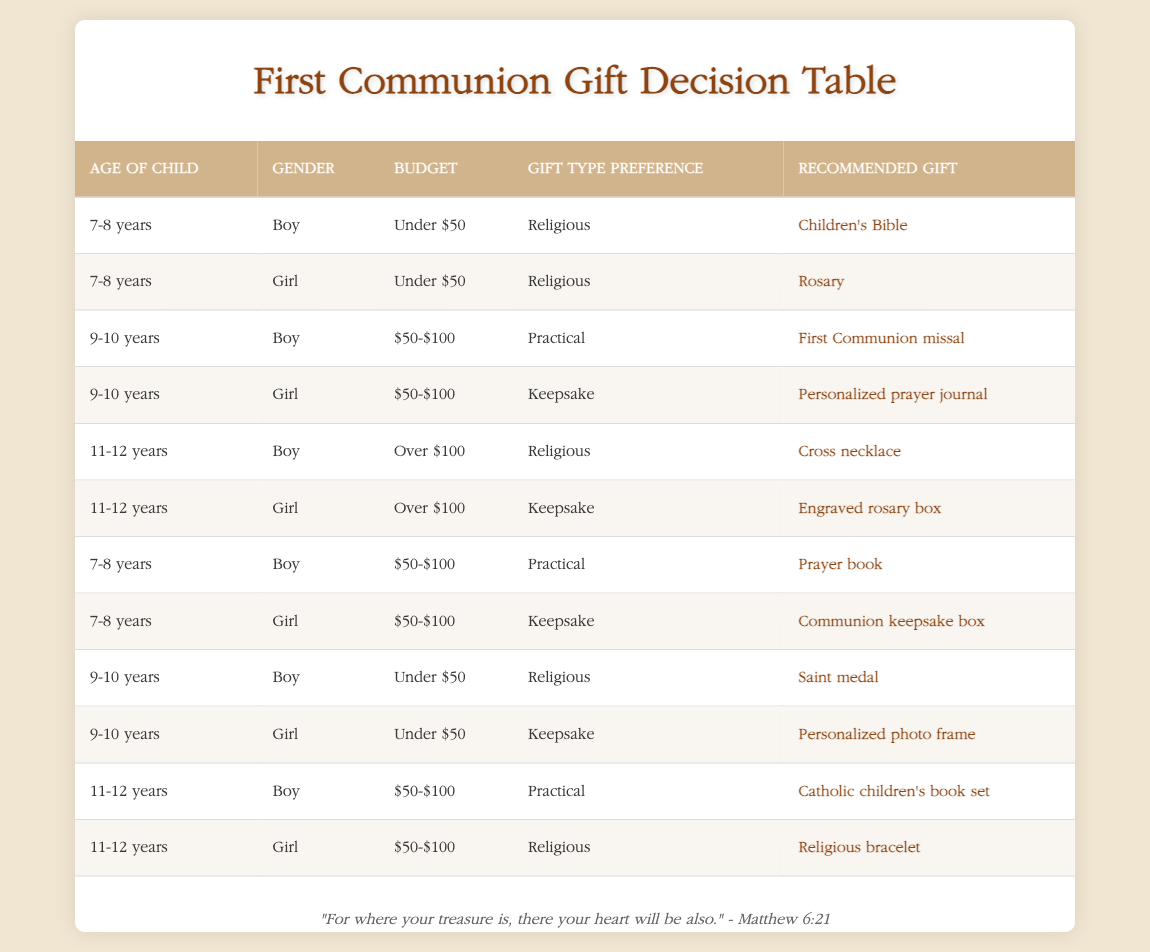What gift is recommended for a 9-10-year-old boy with a budget under $50? According to the table, the conditions for a 9-10-year-old boy with a budget under $50 lead to the action of receiving a Saint medal.
Answer: Saint medal What is the recommended gift for an 11-12-year-old girl with a budget between $50 and $100? The table specifies that for an 11-12-year-old girl with a $50-$100 budget and a preference for religious gifts, the recommended gift is a Religious bracelet.
Answer: Religious bracelet Are there any gifts recommended for 7-8-year-old boys that are practical and cost between $50 and $100? Yes, the table indicates that for 7-8-year-old boys who prefer practical gifts and have a budget of $50-$100, the recommended gift is a Prayer book.
Answer: Yes What is the total number of recommended gifts for 11-12-year-old boys? Looking at the table, the recommendations for 11-12-year-old boys include a Cross necklace, Catholic children's book set, making a total of 2 gifts.
Answer: 2 Is a Personalized prayer journal recommended for 9-10-year-old boys with a budget of $50 to $100? No, based on the table, a Personalized prayer journal is specifically recommended for 9-10-year-old girls with a budget of $50-$100, not for boys.
Answer: No If I have a budget over $100, what religious gift is recommended for an 11-12-year-old boy? The table shows that with a budget over $100 for an 11-12-year-old boy, the recommended religious gift is a Cross necklace.
Answer: Cross necklace For girls aged 7-8, what are the recommended gifts available under $50? The table indicates that for girls aged 7-8 with a budget under $50 and a religious preference, the recommended gift is a Rosary. Thus, there is only one recommendation for this age group and budget.
Answer: Rosary Which gift is suggested for a 9-10-year-old girl who prefers keepsake gifts and has a budget under $50? According to the table, a 9-10-year-old girl with a keepsake preference and budget under $50 would receive a Personalized photo frame as the recommended gift.
Answer: Personalized photo frame In total, how many different gifts are suggested for boys? By examining the table, the gifts recommended for boys include the Children's Bible, Saint medal, Cross necklace, Prayer book, and Catholic children's book set, amounting to a total of 5 different gifts.
Answer: 5 